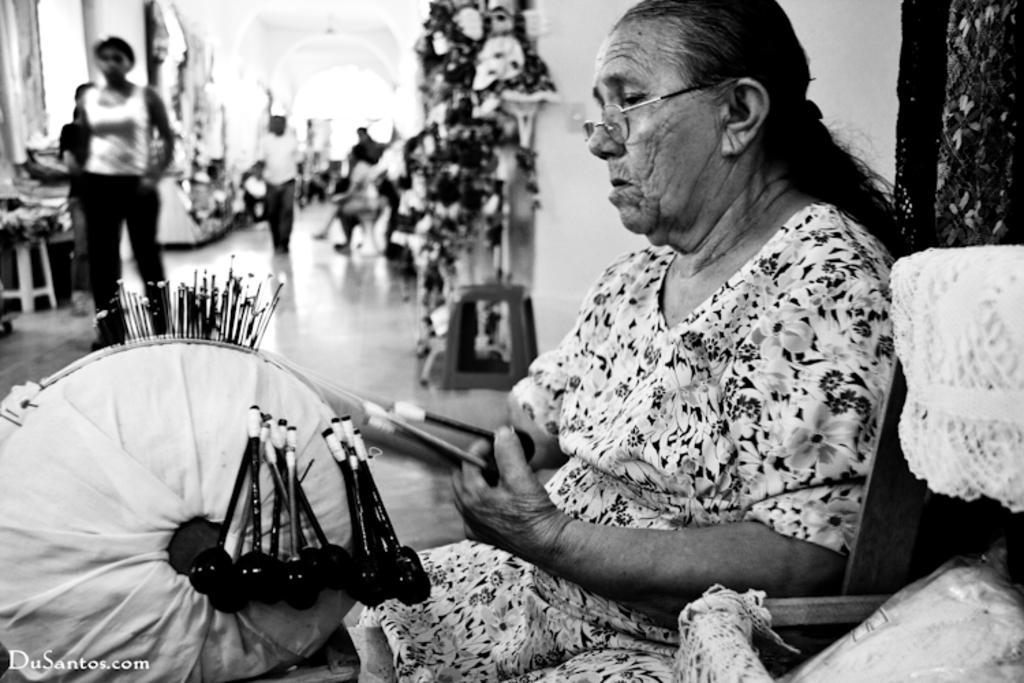Could you give a brief overview of what you see in this image? In the foreground I can see a woman is holding some objects in hand, chair, stool and a wall. In the background I can see a group of people are walking on the floor, some objects, benches and a building. This image is taken may be during a day. 